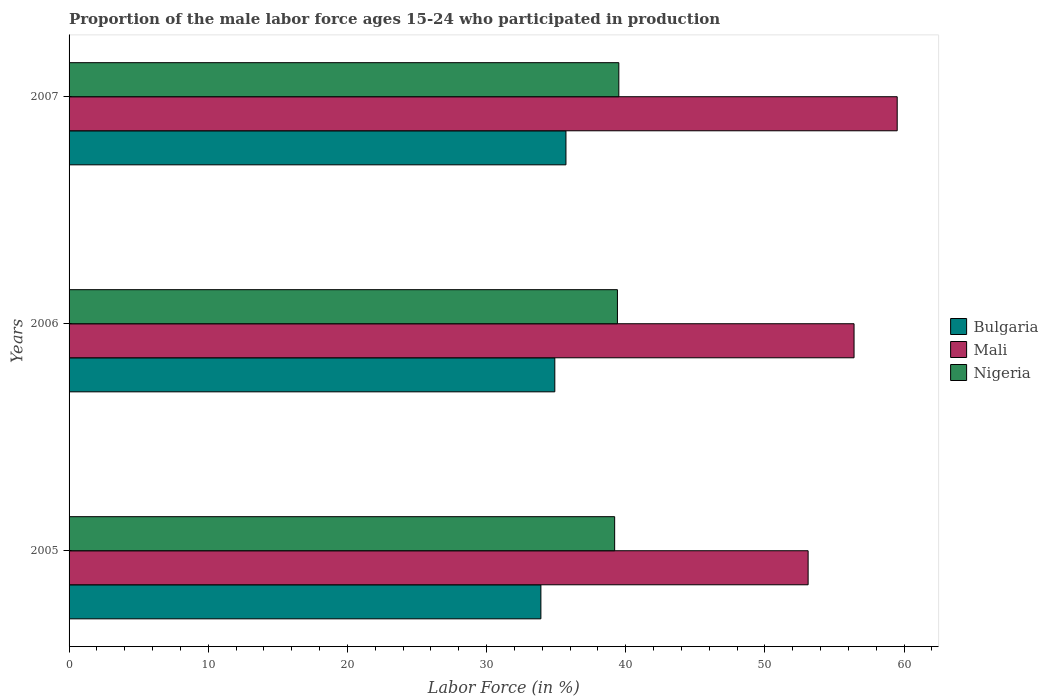How many different coloured bars are there?
Your response must be concise. 3. Are the number of bars per tick equal to the number of legend labels?
Make the answer very short. Yes. Are the number of bars on each tick of the Y-axis equal?
Provide a short and direct response. Yes. How many bars are there on the 2nd tick from the top?
Keep it short and to the point. 3. What is the label of the 3rd group of bars from the top?
Make the answer very short. 2005. What is the proportion of the male labor force who participated in production in Mali in 2005?
Your answer should be very brief. 53.1. Across all years, what is the maximum proportion of the male labor force who participated in production in Nigeria?
Offer a terse response. 39.5. Across all years, what is the minimum proportion of the male labor force who participated in production in Bulgaria?
Provide a short and direct response. 33.9. What is the total proportion of the male labor force who participated in production in Nigeria in the graph?
Give a very brief answer. 118.1. What is the difference between the proportion of the male labor force who participated in production in Nigeria in 2006 and that in 2007?
Keep it short and to the point. -0.1. What is the difference between the proportion of the male labor force who participated in production in Mali in 2006 and the proportion of the male labor force who participated in production in Bulgaria in 2005?
Offer a terse response. 22.5. What is the average proportion of the male labor force who participated in production in Bulgaria per year?
Provide a short and direct response. 34.83. In the year 2007, what is the difference between the proportion of the male labor force who participated in production in Nigeria and proportion of the male labor force who participated in production in Mali?
Provide a succinct answer. -20. What is the ratio of the proportion of the male labor force who participated in production in Mali in 2006 to that in 2007?
Your response must be concise. 0.95. Is the proportion of the male labor force who participated in production in Mali in 2005 less than that in 2006?
Offer a terse response. Yes. Is the difference between the proportion of the male labor force who participated in production in Nigeria in 2006 and 2007 greater than the difference between the proportion of the male labor force who participated in production in Mali in 2006 and 2007?
Your answer should be very brief. Yes. What is the difference between the highest and the second highest proportion of the male labor force who participated in production in Bulgaria?
Your answer should be compact. 0.8. What is the difference between the highest and the lowest proportion of the male labor force who participated in production in Nigeria?
Offer a terse response. 0.3. In how many years, is the proportion of the male labor force who participated in production in Nigeria greater than the average proportion of the male labor force who participated in production in Nigeria taken over all years?
Offer a terse response. 2. What does the 1st bar from the top in 2007 represents?
Provide a succinct answer. Nigeria. What does the 2nd bar from the bottom in 2005 represents?
Provide a short and direct response. Mali. How many bars are there?
Provide a succinct answer. 9. Are all the bars in the graph horizontal?
Offer a terse response. Yes. What is the difference between two consecutive major ticks on the X-axis?
Offer a terse response. 10. Are the values on the major ticks of X-axis written in scientific E-notation?
Offer a very short reply. No. Does the graph contain grids?
Offer a terse response. No. Where does the legend appear in the graph?
Your response must be concise. Center right. How many legend labels are there?
Give a very brief answer. 3. How are the legend labels stacked?
Provide a short and direct response. Vertical. What is the title of the graph?
Your answer should be compact. Proportion of the male labor force ages 15-24 who participated in production. Does "Zimbabwe" appear as one of the legend labels in the graph?
Give a very brief answer. No. What is the label or title of the Y-axis?
Offer a terse response. Years. What is the Labor Force (in %) in Bulgaria in 2005?
Offer a very short reply. 33.9. What is the Labor Force (in %) of Mali in 2005?
Ensure brevity in your answer.  53.1. What is the Labor Force (in %) of Nigeria in 2005?
Your answer should be compact. 39.2. What is the Labor Force (in %) of Bulgaria in 2006?
Offer a very short reply. 34.9. What is the Labor Force (in %) in Mali in 2006?
Offer a very short reply. 56.4. What is the Labor Force (in %) of Nigeria in 2006?
Offer a terse response. 39.4. What is the Labor Force (in %) of Bulgaria in 2007?
Give a very brief answer. 35.7. What is the Labor Force (in %) in Mali in 2007?
Provide a short and direct response. 59.5. What is the Labor Force (in %) of Nigeria in 2007?
Ensure brevity in your answer.  39.5. Across all years, what is the maximum Labor Force (in %) in Bulgaria?
Your response must be concise. 35.7. Across all years, what is the maximum Labor Force (in %) of Mali?
Give a very brief answer. 59.5. Across all years, what is the maximum Labor Force (in %) of Nigeria?
Provide a succinct answer. 39.5. Across all years, what is the minimum Labor Force (in %) of Bulgaria?
Your answer should be compact. 33.9. Across all years, what is the minimum Labor Force (in %) of Mali?
Your answer should be compact. 53.1. Across all years, what is the minimum Labor Force (in %) of Nigeria?
Provide a short and direct response. 39.2. What is the total Labor Force (in %) of Bulgaria in the graph?
Ensure brevity in your answer.  104.5. What is the total Labor Force (in %) of Mali in the graph?
Make the answer very short. 169. What is the total Labor Force (in %) in Nigeria in the graph?
Your answer should be very brief. 118.1. What is the difference between the Labor Force (in %) of Mali in 2005 and that in 2006?
Make the answer very short. -3.3. What is the difference between the Labor Force (in %) of Bulgaria in 2006 and that in 2007?
Your response must be concise. -0.8. What is the difference between the Labor Force (in %) in Bulgaria in 2005 and the Labor Force (in %) in Mali in 2006?
Provide a succinct answer. -22.5. What is the difference between the Labor Force (in %) of Bulgaria in 2005 and the Labor Force (in %) of Nigeria in 2006?
Offer a terse response. -5.5. What is the difference between the Labor Force (in %) of Mali in 2005 and the Labor Force (in %) of Nigeria in 2006?
Ensure brevity in your answer.  13.7. What is the difference between the Labor Force (in %) in Bulgaria in 2005 and the Labor Force (in %) in Mali in 2007?
Your answer should be compact. -25.6. What is the difference between the Labor Force (in %) of Bulgaria in 2005 and the Labor Force (in %) of Nigeria in 2007?
Make the answer very short. -5.6. What is the difference between the Labor Force (in %) in Bulgaria in 2006 and the Labor Force (in %) in Mali in 2007?
Give a very brief answer. -24.6. What is the average Labor Force (in %) of Bulgaria per year?
Provide a short and direct response. 34.83. What is the average Labor Force (in %) of Mali per year?
Your answer should be compact. 56.33. What is the average Labor Force (in %) in Nigeria per year?
Provide a short and direct response. 39.37. In the year 2005, what is the difference between the Labor Force (in %) of Bulgaria and Labor Force (in %) of Mali?
Offer a terse response. -19.2. In the year 2005, what is the difference between the Labor Force (in %) of Mali and Labor Force (in %) of Nigeria?
Offer a terse response. 13.9. In the year 2006, what is the difference between the Labor Force (in %) of Bulgaria and Labor Force (in %) of Mali?
Keep it short and to the point. -21.5. In the year 2006, what is the difference between the Labor Force (in %) of Bulgaria and Labor Force (in %) of Nigeria?
Give a very brief answer. -4.5. In the year 2006, what is the difference between the Labor Force (in %) in Mali and Labor Force (in %) in Nigeria?
Keep it short and to the point. 17. In the year 2007, what is the difference between the Labor Force (in %) in Bulgaria and Labor Force (in %) in Mali?
Keep it short and to the point. -23.8. In the year 2007, what is the difference between the Labor Force (in %) in Mali and Labor Force (in %) in Nigeria?
Provide a succinct answer. 20. What is the ratio of the Labor Force (in %) in Bulgaria in 2005 to that in 2006?
Keep it short and to the point. 0.97. What is the ratio of the Labor Force (in %) in Mali in 2005 to that in 2006?
Offer a very short reply. 0.94. What is the ratio of the Labor Force (in %) in Nigeria in 2005 to that in 2006?
Provide a short and direct response. 0.99. What is the ratio of the Labor Force (in %) in Bulgaria in 2005 to that in 2007?
Your answer should be compact. 0.95. What is the ratio of the Labor Force (in %) in Mali in 2005 to that in 2007?
Provide a short and direct response. 0.89. What is the ratio of the Labor Force (in %) in Bulgaria in 2006 to that in 2007?
Offer a terse response. 0.98. What is the ratio of the Labor Force (in %) in Mali in 2006 to that in 2007?
Give a very brief answer. 0.95. What is the ratio of the Labor Force (in %) of Nigeria in 2006 to that in 2007?
Your answer should be very brief. 1. What is the difference between the highest and the second highest Labor Force (in %) in Mali?
Offer a terse response. 3.1. What is the difference between the highest and the lowest Labor Force (in %) of Nigeria?
Offer a very short reply. 0.3. 